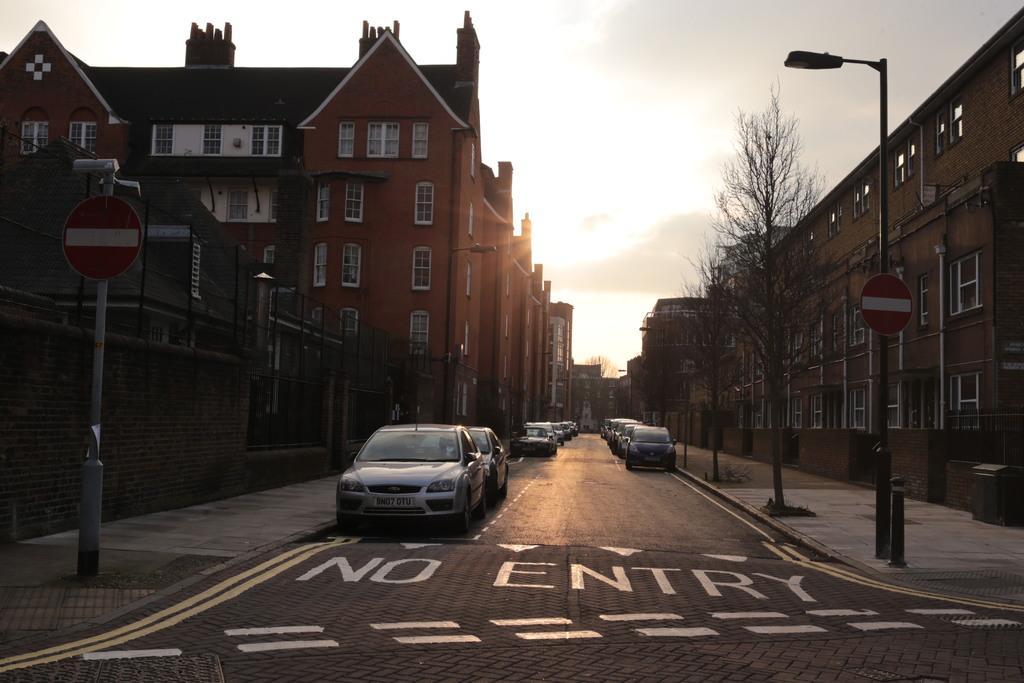Please provide a concise description of this image. In this image I can see few buildings, windows, trees, light pole, sign boards, poles, fencing and few vehicles on the road. The sky is in white color. 